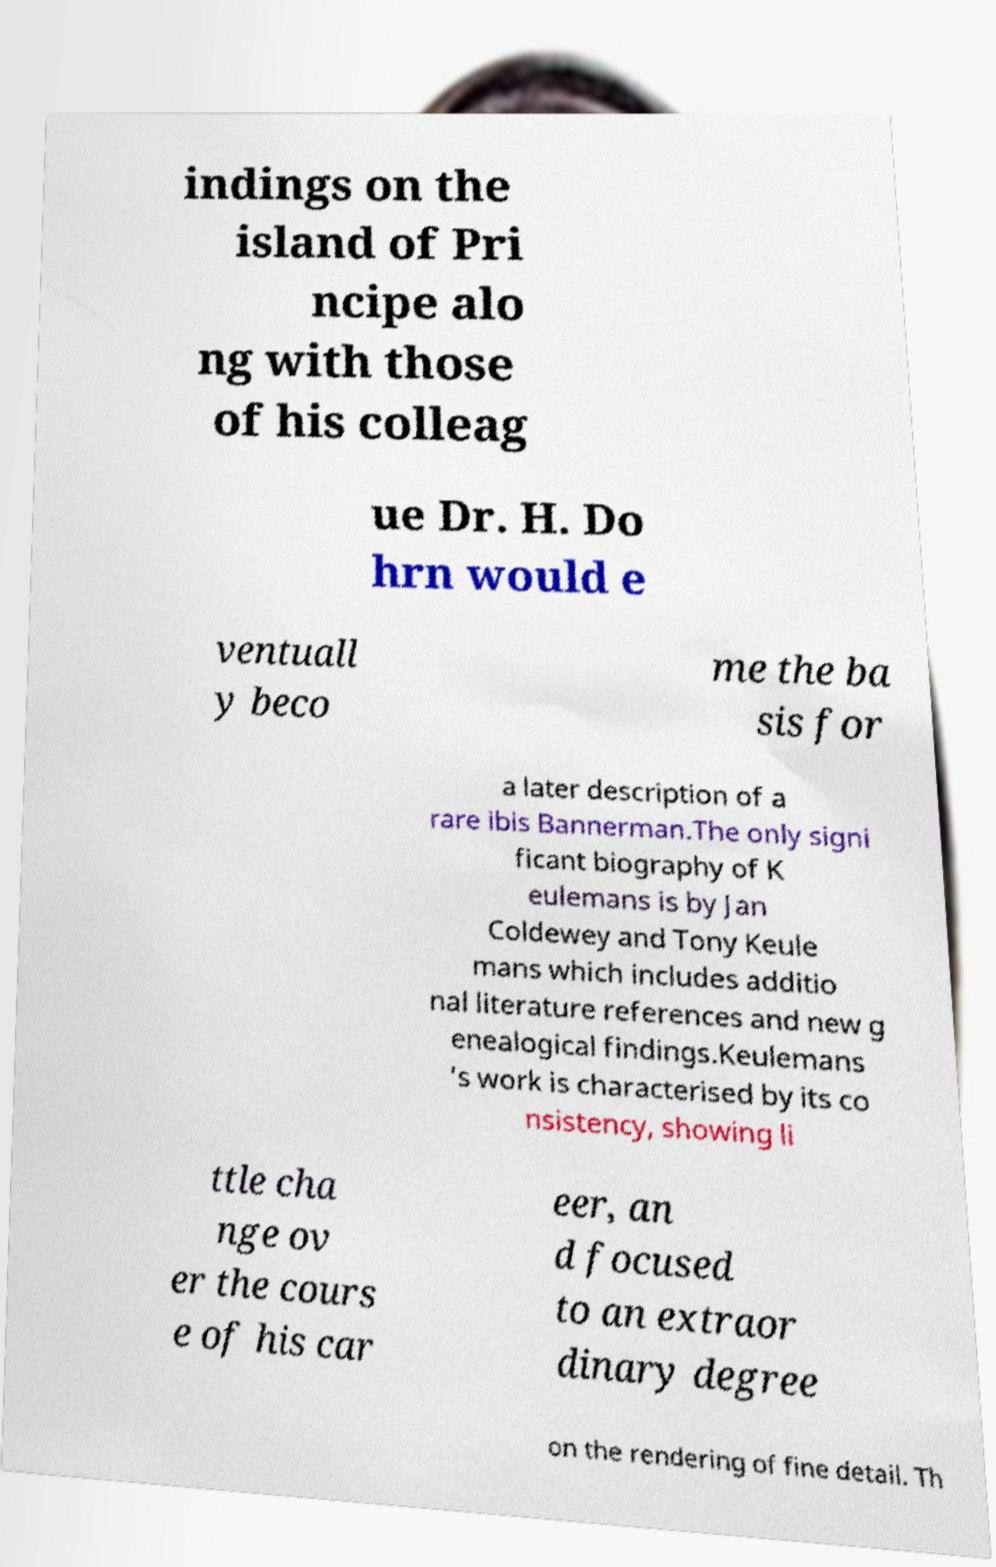Please identify and transcribe the text found in this image. indings on the island of Pri ncipe alo ng with those of his colleag ue Dr. H. Do hrn would e ventuall y beco me the ba sis for a later description of a rare ibis Bannerman.The only signi ficant biography of K eulemans is by Jan Coldewey and Tony Keule mans which includes additio nal literature references and new g enealogical findings.Keulemans 's work is characterised by its co nsistency, showing li ttle cha nge ov er the cours e of his car eer, an d focused to an extraor dinary degree on the rendering of fine detail. Th 